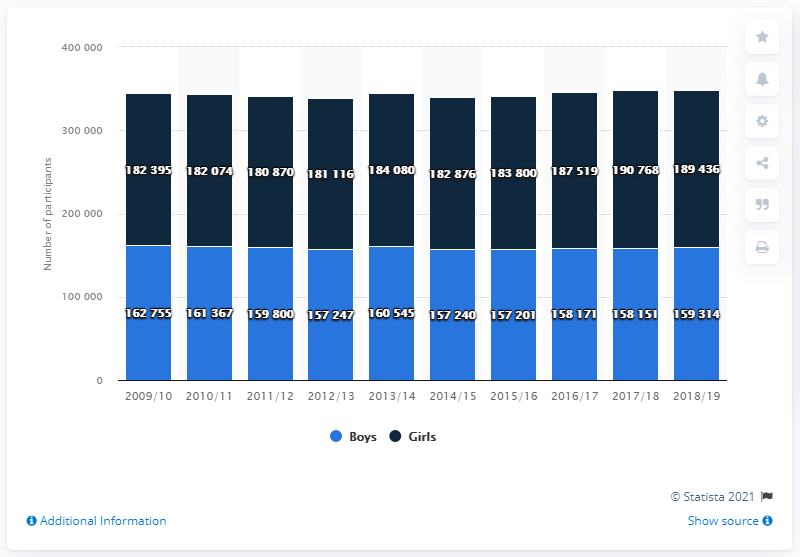Identify some key points in this picture. The difference between the lowest participants in girls and the highest participants in boys is 18115. During the 2018/19 high school tennis season, a total of 18,9436 girls participated in the program. The availability of information on US high school tennis can be traced back to 2009. 